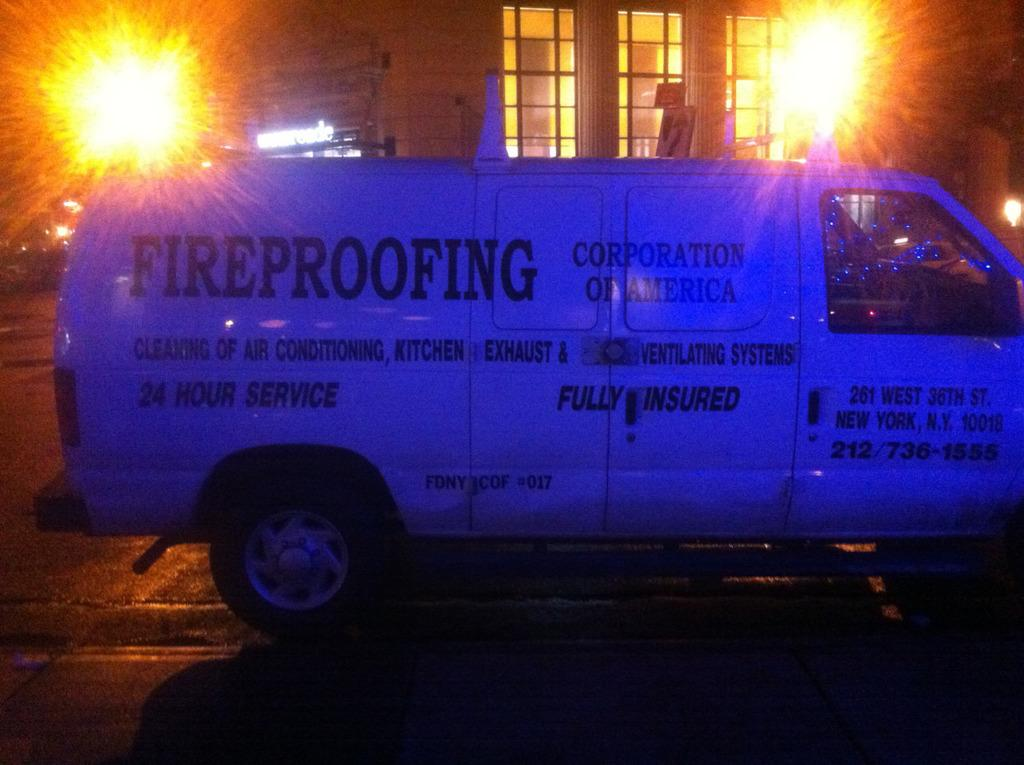<image>
Give a short and clear explanation of the subsequent image. A white, commercial van, owned by a company that fire proofs buildings, is parked outside a house, at night. 